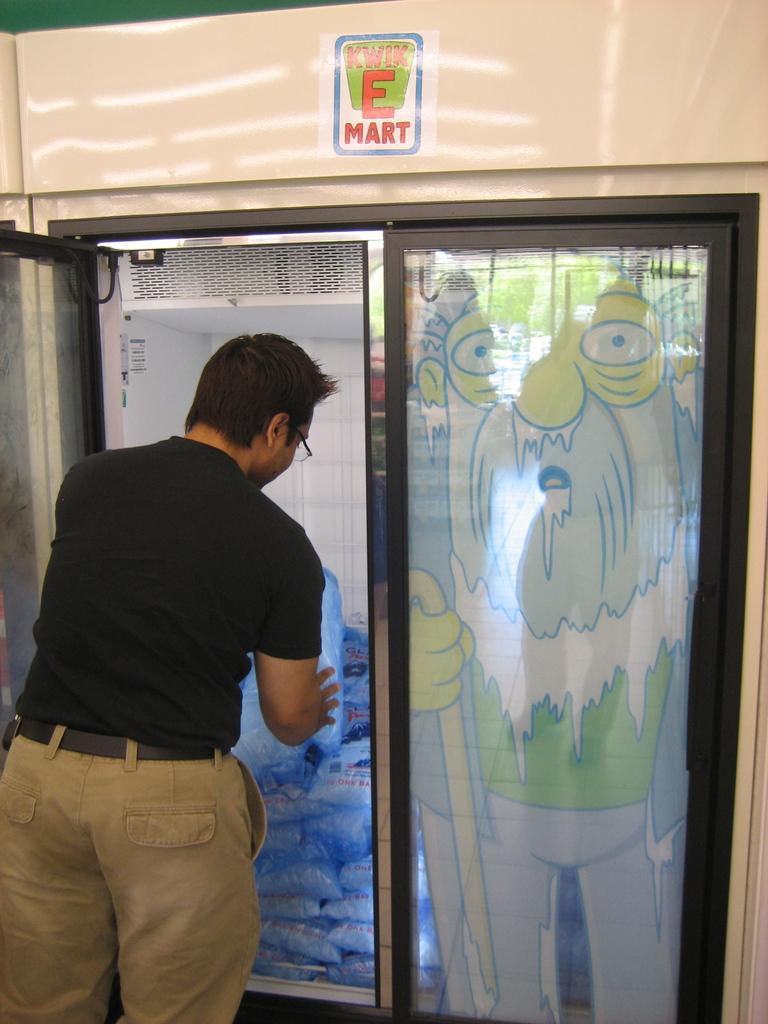<image>
Provide a brief description of the given image. A man pulls a bag of ice from a freezer labeled Kwik E Mart. 